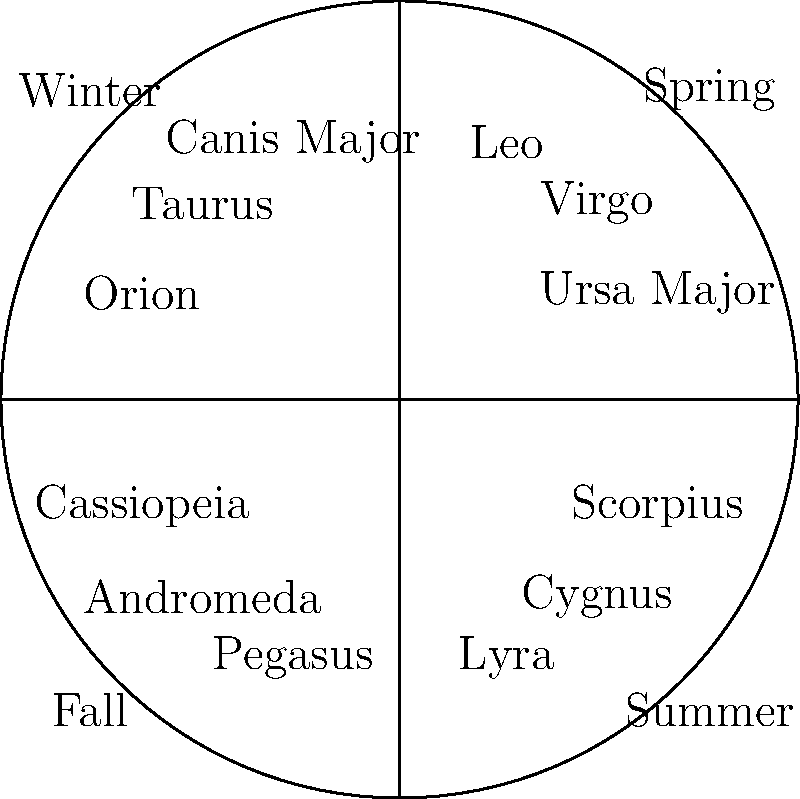As you prepare for your pre-game ritual of listening to the national anthem, you gaze up at the night sky. Which constellation would you most likely see prominently displayed during the winter months in the Northern Hemisphere? To answer this question, let's break it down step-by-step:

1. The question is asking about constellations visible during winter in the Northern Hemisphere.

2. Constellations appear to change throughout the year due to Earth's rotation around the Sun. This causes different parts of the night sky to be visible during different seasons.

3. In the provided chart, we can see the constellations grouped by season:
   - Spring: Leo, Virgo, Ursa Major
   - Summer: Scorpius, Cygnus, Lyra
   - Fall: Pegasus, Andromeda, Cassiopeia
   - Winter: Orion, Taurus, Canis Major

4. Looking at the winter section, we see three prominent constellations: Orion, Taurus, and Canis Major.

5. Among these, Orion is often considered the most recognizable and prominent winter constellation in the Northern Hemisphere. It's known for its distinctive "belt" of three aligned stars and is often used as a starting point for identifying other winter constellations.

Therefore, while all three winter constellations listed would be visible, Orion is typically the most prominent and easily recognizable.
Answer: Orion 